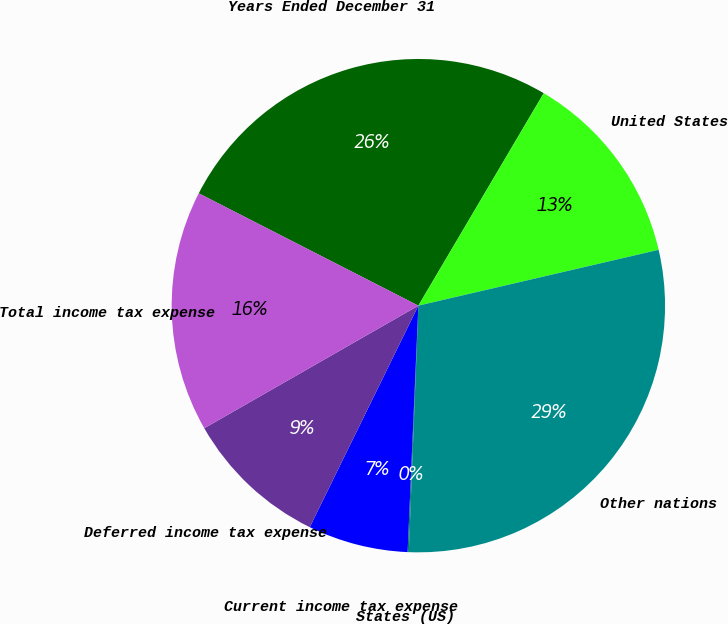Convert chart to OTSL. <chart><loc_0><loc_0><loc_500><loc_500><pie_chart><fcel>Years Ended December 31<fcel>United States<fcel>Other nations<fcel>States (US)<fcel>Current income tax expense<fcel>Deferred income tax expense<fcel>Total income tax expense<nl><fcel>25.96%<fcel>12.88%<fcel>29.25%<fcel>0.08%<fcel>6.56%<fcel>9.47%<fcel>15.8%<nl></chart> 